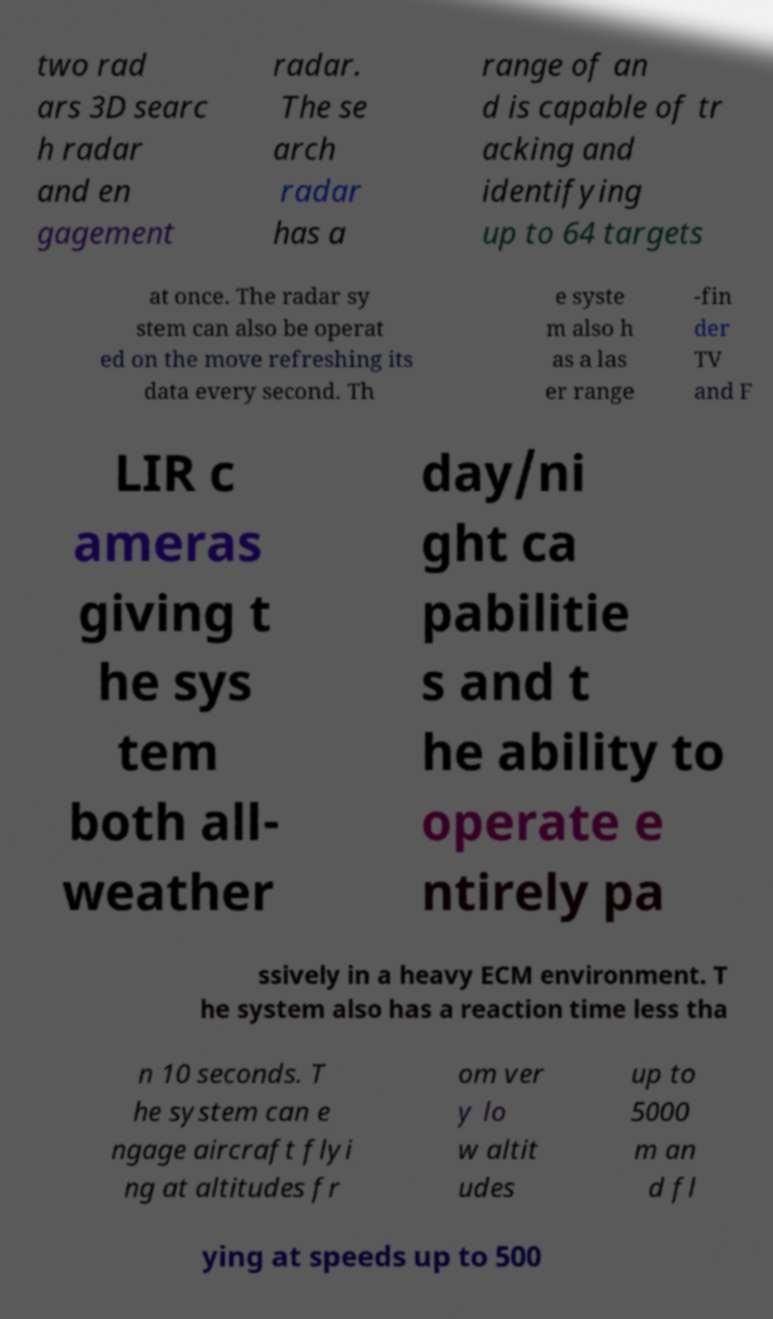What messages or text are displayed in this image? I need them in a readable, typed format. two rad ars 3D searc h radar and en gagement radar. The se arch radar has a range of an d is capable of tr acking and identifying up to 64 targets at once. The radar sy stem can also be operat ed on the move refreshing its data every second. Th e syste m also h as a las er range -fin der TV and F LIR c ameras giving t he sys tem both all- weather day/ni ght ca pabilitie s and t he ability to operate e ntirely pa ssively in a heavy ECM environment. T he system also has a reaction time less tha n 10 seconds. T he system can e ngage aircraft flyi ng at altitudes fr om ver y lo w altit udes up to 5000 m an d fl ying at speeds up to 500 